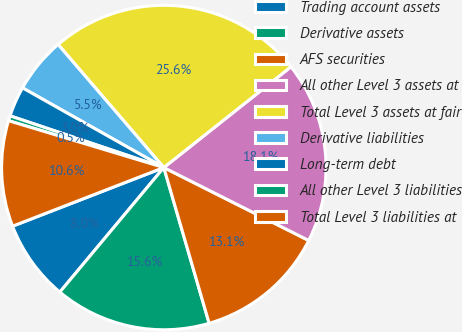Convert chart. <chart><loc_0><loc_0><loc_500><loc_500><pie_chart><fcel>Trading account assets<fcel>Derivative assets<fcel>AFS securities<fcel>All other Level 3 assets at<fcel>Total Level 3 assets at fair<fcel>Derivative liabilities<fcel>Long-term debt<fcel>All other Level 3 liabilities<fcel>Total Level 3 liabilities at<nl><fcel>8.04%<fcel>15.58%<fcel>13.07%<fcel>18.09%<fcel>25.63%<fcel>5.53%<fcel>3.01%<fcel>0.5%<fcel>10.55%<nl></chart> 